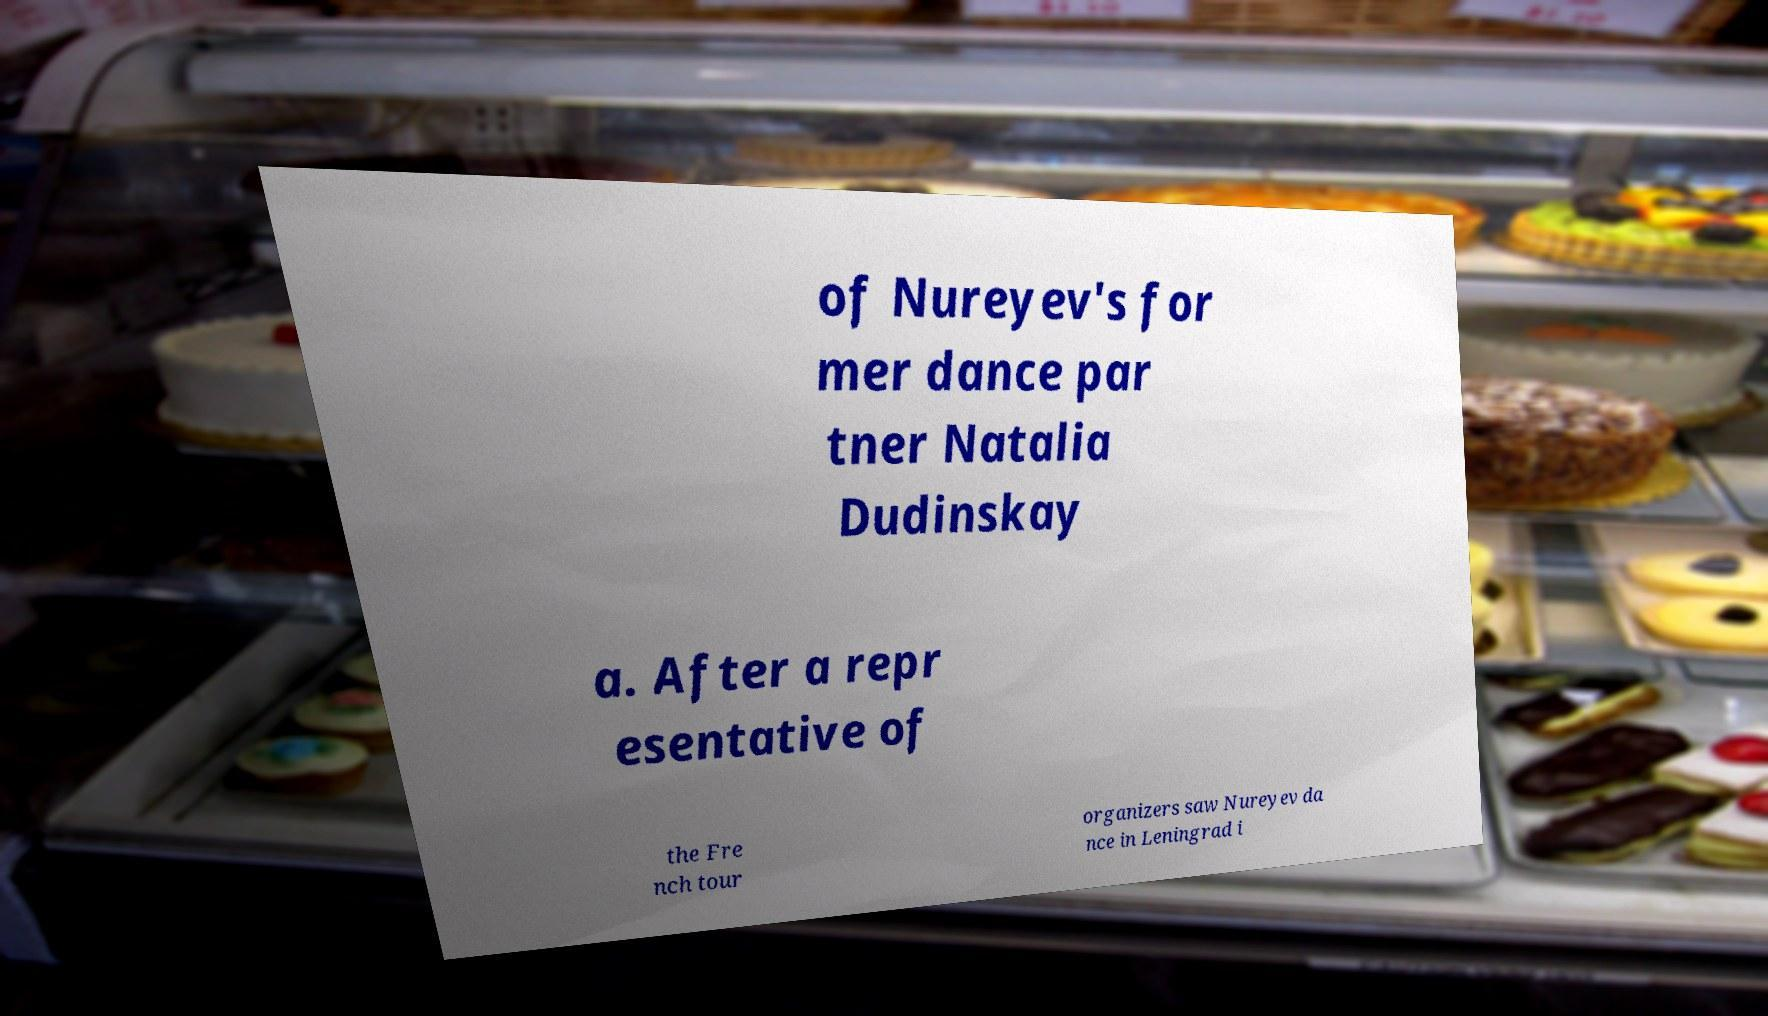For documentation purposes, I need the text within this image transcribed. Could you provide that? of Nureyev's for mer dance par tner Natalia Dudinskay a. After a repr esentative of the Fre nch tour organizers saw Nureyev da nce in Leningrad i 